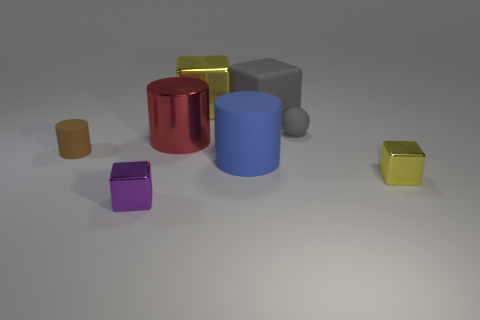Subtract all big yellow shiny blocks. How many blocks are left? 3 Add 2 things. How many objects exist? 10 Subtract all spheres. How many objects are left? 7 Subtract 1 cylinders. How many cylinders are left? 2 Subtract all cyan spheres. How many yellow cubes are left? 2 Subtract all large matte cylinders. Subtract all tiny yellow metal blocks. How many objects are left? 6 Add 7 tiny gray matte objects. How many tiny gray matte objects are left? 8 Add 7 large gray matte cubes. How many large gray matte cubes exist? 8 Subtract all yellow cubes. How many cubes are left? 2 Subtract 0 red balls. How many objects are left? 8 